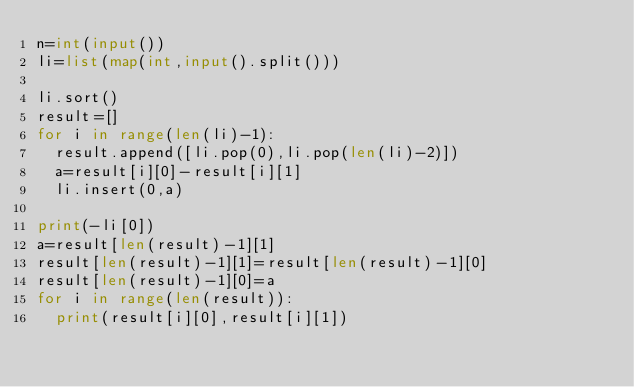Convert code to text. <code><loc_0><loc_0><loc_500><loc_500><_Python_>n=int(input())
li=list(map(int,input().split()))

li.sort()
result=[]
for i in range(len(li)-1):
  result.append([li.pop(0),li.pop(len(li)-2)])
  a=result[i][0]-result[i][1]
  li.insert(0,a)
  
print(-li[0])
a=result[len(result)-1][1]
result[len(result)-1][1]=result[len(result)-1][0]
result[len(result)-1][0]=a
for i in range(len(result)):
  print(result[i][0],result[i][1])
  </code> 